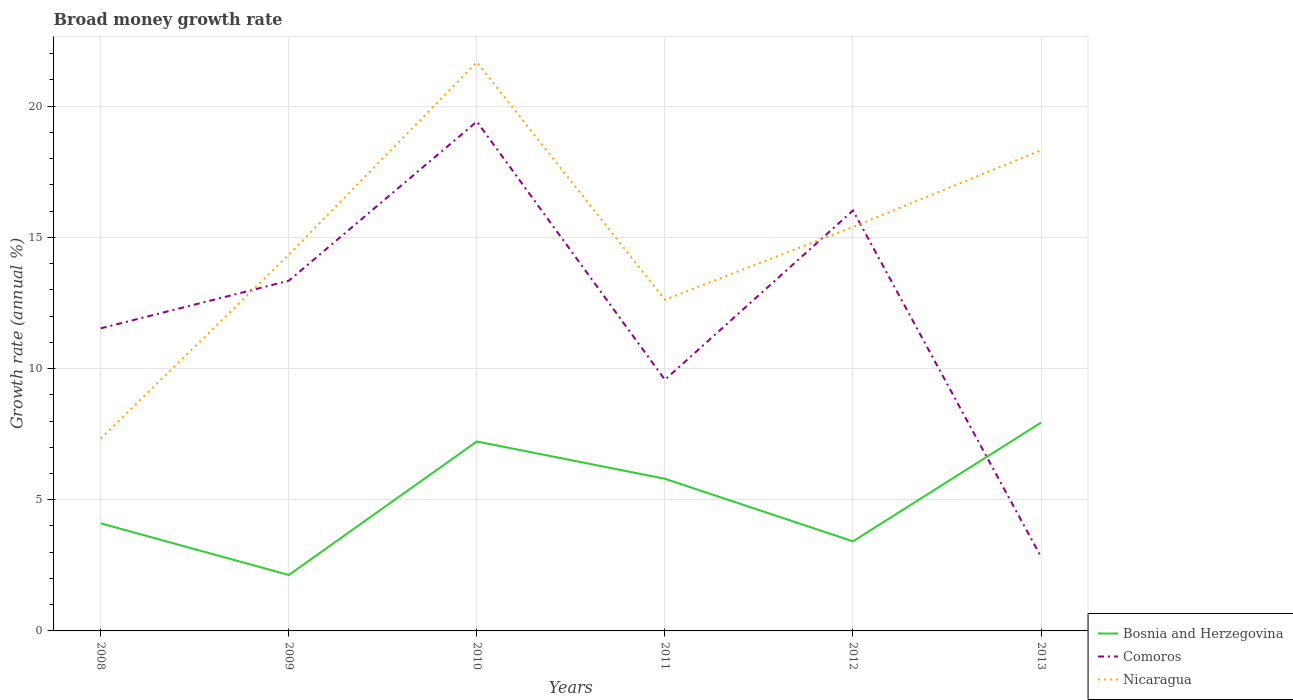Does the line corresponding to Bosnia and Herzegovina intersect with the line corresponding to Nicaragua?
Provide a succinct answer. No. Is the number of lines equal to the number of legend labels?
Ensure brevity in your answer.  Yes. Across all years, what is the maximum growth rate in Comoros?
Offer a very short reply. 2.82. What is the total growth rate in Comoros in the graph?
Your answer should be very brief. -6.45. What is the difference between the highest and the second highest growth rate in Bosnia and Herzegovina?
Give a very brief answer. 5.81. How many lines are there?
Offer a very short reply. 3. How many years are there in the graph?
Provide a succinct answer. 6. Are the values on the major ticks of Y-axis written in scientific E-notation?
Keep it short and to the point. No. Does the graph contain any zero values?
Provide a succinct answer. No. Does the graph contain grids?
Make the answer very short. Yes. Where does the legend appear in the graph?
Provide a short and direct response. Bottom right. How are the legend labels stacked?
Offer a very short reply. Vertical. What is the title of the graph?
Make the answer very short. Broad money growth rate. Does "Lao PDR" appear as one of the legend labels in the graph?
Your response must be concise. No. What is the label or title of the Y-axis?
Your answer should be compact. Growth rate (annual %). What is the Growth rate (annual %) of Bosnia and Herzegovina in 2008?
Make the answer very short. 4.1. What is the Growth rate (annual %) in Comoros in 2008?
Ensure brevity in your answer.  11.53. What is the Growth rate (annual %) in Nicaragua in 2008?
Keep it short and to the point. 7.33. What is the Growth rate (annual %) in Bosnia and Herzegovina in 2009?
Your answer should be compact. 2.13. What is the Growth rate (annual %) in Comoros in 2009?
Your response must be concise. 13.34. What is the Growth rate (annual %) of Nicaragua in 2009?
Your response must be concise. 14.34. What is the Growth rate (annual %) of Bosnia and Herzegovina in 2010?
Your answer should be very brief. 7.22. What is the Growth rate (annual %) in Comoros in 2010?
Offer a terse response. 19.41. What is the Growth rate (annual %) in Nicaragua in 2010?
Provide a short and direct response. 21.67. What is the Growth rate (annual %) of Bosnia and Herzegovina in 2011?
Provide a short and direct response. 5.8. What is the Growth rate (annual %) in Comoros in 2011?
Your response must be concise. 9.57. What is the Growth rate (annual %) in Nicaragua in 2011?
Give a very brief answer. 12.62. What is the Growth rate (annual %) of Bosnia and Herzegovina in 2012?
Ensure brevity in your answer.  3.41. What is the Growth rate (annual %) in Comoros in 2012?
Give a very brief answer. 16.02. What is the Growth rate (annual %) in Nicaragua in 2012?
Your answer should be very brief. 15.39. What is the Growth rate (annual %) in Bosnia and Herzegovina in 2013?
Provide a short and direct response. 7.94. What is the Growth rate (annual %) of Comoros in 2013?
Your answer should be very brief. 2.82. What is the Growth rate (annual %) in Nicaragua in 2013?
Your response must be concise. 18.32. Across all years, what is the maximum Growth rate (annual %) in Bosnia and Herzegovina?
Ensure brevity in your answer.  7.94. Across all years, what is the maximum Growth rate (annual %) in Comoros?
Keep it short and to the point. 19.41. Across all years, what is the maximum Growth rate (annual %) in Nicaragua?
Your answer should be very brief. 21.67. Across all years, what is the minimum Growth rate (annual %) in Bosnia and Herzegovina?
Offer a very short reply. 2.13. Across all years, what is the minimum Growth rate (annual %) of Comoros?
Ensure brevity in your answer.  2.82. Across all years, what is the minimum Growth rate (annual %) of Nicaragua?
Make the answer very short. 7.33. What is the total Growth rate (annual %) of Bosnia and Herzegovina in the graph?
Your response must be concise. 30.6. What is the total Growth rate (annual %) in Comoros in the graph?
Your answer should be compact. 72.7. What is the total Growth rate (annual %) in Nicaragua in the graph?
Give a very brief answer. 89.68. What is the difference between the Growth rate (annual %) in Bosnia and Herzegovina in 2008 and that in 2009?
Your response must be concise. 1.97. What is the difference between the Growth rate (annual %) in Comoros in 2008 and that in 2009?
Your answer should be very brief. -1.81. What is the difference between the Growth rate (annual %) in Nicaragua in 2008 and that in 2009?
Offer a very short reply. -7.01. What is the difference between the Growth rate (annual %) in Bosnia and Herzegovina in 2008 and that in 2010?
Offer a terse response. -3.12. What is the difference between the Growth rate (annual %) of Comoros in 2008 and that in 2010?
Provide a short and direct response. -7.88. What is the difference between the Growth rate (annual %) in Nicaragua in 2008 and that in 2010?
Provide a succinct answer. -14.34. What is the difference between the Growth rate (annual %) in Bosnia and Herzegovina in 2008 and that in 2011?
Give a very brief answer. -1.7. What is the difference between the Growth rate (annual %) of Comoros in 2008 and that in 2011?
Offer a very short reply. 1.96. What is the difference between the Growth rate (annual %) in Nicaragua in 2008 and that in 2011?
Your answer should be very brief. -5.29. What is the difference between the Growth rate (annual %) in Bosnia and Herzegovina in 2008 and that in 2012?
Your answer should be compact. 0.69. What is the difference between the Growth rate (annual %) of Comoros in 2008 and that in 2012?
Ensure brevity in your answer.  -4.49. What is the difference between the Growth rate (annual %) of Nicaragua in 2008 and that in 2012?
Make the answer very short. -8.06. What is the difference between the Growth rate (annual %) of Bosnia and Herzegovina in 2008 and that in 2013?
Your answer should be compact. -3.84. What is the difference between the Growth rate (annual %) of Comoros in 2008 and that in 2013?
Ensure brevity in your answer.  8.71. What is the difference between the Growth rate (annual %) of Nicaragua in 2008 and that in 2013?
Your answer should be compact. -10.99. What is the difference between the Growth rate (annual %) of Bosnia and Herzegovina in 2009 and that in 2010?
Make the answer very short. -5.09. What is the difference between the Growth rate (annual %) in Comoros in 2009 and that in 2010?
Your response must be concise. -6.07. What is the difference between the Growth rate (annual %) in Nicaragua in 2009 and that in 2010?
Your response must be concise. -7.33. What is the difference between the Growth rate (annual %) of Bosnia and Herzegovina in 2009 and that in 2011?
Your response must be concise. -3.67. What is the difference between the Growth rate (annual %) of Comoros in 2009 and that in 2011?
Offer a very short reply. 3.77. What is the difference between the Growth rate (annual %) of Nicaragua in 2009 and that in 2011?
Your answer should be compact. 1.72. What is the difference between the Growth rate (annual %) of Bosnia and Herzegovina in 2009 and that in 2012?
Your response must be concise. -1.28. What is the difference between the Growth rate (annual %) in Comoros in 2009 and that in 2012?
Give a very brief answer. -2.68. What is the difference between the Growth rate (annual %) of Nicaragua in 2009 and that in 2012?
Offer a terse response. -1.05. What is the difference between the Growth rate (annual %) in Bosnia and Herzegovina in 2009 and that in 2013?
Give a very brief answer. -5.81. What is the difference between the Growth rate (annual %) in Comoros in 2009 and that in 2013?
Offer a very short reply. 10.52. What is the difference between the Growth rate (annual %) in Nicaragua in 2009 and that in 2013?
Provide a succinct answer. -3.98. What is the difference between the Growth rate (annual %) of Bosnia and Herzegovina in 2010 and that in 2011?
Ensure brevity in your answer.  1.42. What is the difference between the Growth rate (annual %) in Comoros in 2010 and that in 2011?
Your response must be concise. 9.84. What is the difference between the Growth rate (annual %) in Nicaragua in 2010 and that in 2011?
Your answer should be very brief. 9.05. What is the difference between the Growth rate (annual %) of Bosnia and Herzegovina in 2010 and that in 2012?
Ensure brevity in your answer.  3.8. What is the difference between the Growth rate (annual %) in Comoros in 2010 and that in 2012?
Offer a very short reply. 3.39. What is the difference between the Growth rate (annual %) in Nicaragua in 2010 and that in 2012?
Offer a terse response. 6.28. What is the difference between the Growth rate (annual %) of Bosnia and Herzegovina in 2010 and that in 2013?
Ensure brevity in your answer.  -0.72. What is the difference between the Growth rate (annual %) in Comoros in 2010 and that in 2013?
Your answer should be compact. 16.59. What is the difference between the Growth rate (annual %) of Nicaragua in 2010 and that in 2013?
Your answer should be compact. 3.35. What is the difference between the Growth rate (annual %) in Bosnia and Herzegovina in 2011 and that in 2012?
Your answer should be compact. 2.38. What is the difference between the Growth rate (annual %) of Comoros in 2011 and that in 2012?
Make the answer very short. -6.45. What is the difference between the Growth rate (annual %) in Nicaragua in 2011 and that in 2012?
Offer a terse response. -2.77. What is the difference between the Growth rate (annual %) of Bosnia and Herzegovina in 2011 and that in 2013?
Keep it short and to the point. -2.14. What is the difference between the Growth rate (annual %) of Comoros in 2011 and that in 2013?
Provide a succinct answer. 6.75. What is the difference between the Growth rate (annual %) in Nicaragua in 2011 and that in 2013?
Your answer should be very brief. -5.7. What is the difference between the Growth rate (annual %) of Bosnia and Herzegovina in 2012 and that in 2013?
Provide a succinct answer. -4.53. What is the difference between the Growth rate (annual %) in Comoros in 2012 and that in 2013?
Provide a short and direct response. 13.2. What is the difference between the Growth rate (annual %) of Nicaragua in 2012 and that in 2013?
Make the answer very short. -2.93. What is the difference between the Growth rate (annual %) in Bosnia and Herzegovina in 2008 and the Growth rate (annual %) in Comoros in 2009?
Make the answer very short. -9.24. What is the difference between the Growth rate (annual %) in Bosnia and Herzegovina in 2008 and the Growth rate (annual %) in Nicaragua in 2009?
Offer a very short reply. -10.24. What is the difference between the Growth rate (annual %) of Comoros in 2008 and the Growth rate (annual %) of Nicaragua in 2009?
Offer a very short reply. -2.81. What is the difference between the Growth rate (annual %) in Bosnia and Herzegovina in 2008 and the Growth rate (annual %) in Comoros in 2010?
Your answer should be compact. -15.31. What is the difference between the Growth rate (annual %) in Bosnia and Herzegovina in 2008 and the Growth rate (annual %) in Nicaragua in 2010?
Your answer should be very brief. -17.57. What is the difference between the Growth rate (annual %) in Comoros in 2008 and the Growth rate (annual %) in Nicaragua in 2010?
Give a very brief answer. -10.14. What is the difference between the Growth rate (annual %) in Bosnia and Herzegovina in 2008 and the Growth rate (annual %) in Comoros in 2011?
Provide a succinct answer. -5.47. What is the difference between the Growth rate (annual %) of Bosnia and Herzegovina in 2008 and the Growth rate (annual %) of Nicaragua in 2011?
Keep it short and to the point. -8.52. What is the difference between the Growth rate (annual %) of Comoros in 2008 and the Growth rate (annual %) of Nicaragua in 2011?
Give a very brief answer. -1.09. What is the difference between the Growth rate (annual %) in Bosnia and Herzegovina in 2008 and the Growth rate (annual %) in Comoros in 2012?
Ensure brevity in your answer.  -11.92. What is the difference between the Growth rate (annual %) in Bosnia and Herzegovina in 2008 and the Growth rate (annual %) in Nicaragua in 2012?
Keep it short and to the point. -11.29. What is the difference between the Growth rate (annual %) in Comoros in 2008 and the Growth rate (annual %) in Nicaragua in 2012?
Make the answer very short. -3.86. What is the difference between the Growth rate (annual %) of Bosnia and Herzegovina in 2008 and the Growth rate (annual %) of Comoros in 2013?
Ensure brevity in your answer.  1.28. What is the difference between the Growth rate (annual %) of Bosnia and Herzegovina in 2008 and the Growth rate (annual %) of Nicaragua in 2013?
Offer a terse response. -14.22. What is the difference between the Growth rate (annual %) of Comoros in 2008 and the Growth rate (annual %) of Nicaragua in 2013?
Provide a short and direct response. -6.79. What is the difference between the Growth rate (annual %) in Bosnia and Herzegovina in 2009 and the Growth rate (annual %) in Comoros in 2010?
Offer a terse response. -17.28. What is the difference between the Growth rate (annual %) of Bosnia and Herzegovina in 2009 and the Growth rate (annual %) of Nicaragua in 2010?
Offer a very short reply. -19.54. What is the difference between the Growth rate (annual %) in Comoros in 2009 and the Growth rate (annual %) in Nicaragua in 2010?
Keep it short and to the point. -8.33. What is the difference between the Growth rate (annual %) in Bosnia and Herzegovina in 2009 and the Growth rate (annual %) in Comoros in 2011?
Keep it short and to the point. -7.44. What is the difference between the Growth rate (annual %) in Bosnia and Herzegovina in 2009 and the Growth rate (annual %) in Nicaragua in 2011?
Your answer should be compact. -10.49. What is the difference between the Growth rate (annual %) of Comoros in 2009 and the Growth rate (annual %) of Nicaragua in 2011?
Ensure brevity in your answer.  0.72. What is the difference between the Growth rate (annual %) of Bosnia and Herzegovina in 2009 and the Growth rate (annual %) of Comoros in 2012?
Provide a short and direct response. -13.89. What is the difference between the Growth rate (annual %) in Bosnia and Herzegovina in 2009 and the Growth rate (annual %) in Nicaragua in 2012?
Ensure brevity in your answer.  -13.26. What is the difference between the Growth rate (annual %) of Comoros in 2009 and the Growth rate (annual %) of Nicaragua in 2012?
Provide a short and direct response. -2.05. What is the difference between the Growth rate (annual %) of Bosnia and Herzegovina in 2009 and the Growth rate (annual %) of Comoros in 2013?
Offer a very short reply. -0.69. What is the difference between the Growth rate (annual %) in Bosnia and Herzegovina in 2009 and the Growth rate (annual %) in Nicaragua in 2013?
Your answer should be compact. -16.19. What is the difference between the Growth rate (annual %) of Comoros in 2009 and the Growth rate (annual %) of Nicaragua in 2013?
Your answer should be very brief. -4.97. What is the difference between the Growth rate (annual %) of Bosnia and Herzegovina in 2010 and the Growth rate (annual %) of Comoros in 2011?
Your answer should be very brief. -2.35. What is the difference between the Growth rate (annual %) of Bosnia and Herzegovina in 2010 and the Growth rate (annual %) of Nicaragua in 2011?
Offer a very short reply. -5.4. What is the difference between the Growth rate (annual %) of Comoros in 2010 and the Growth rate (annual %) of Nicaragua in 2011?
Make the answer very short. 6.79. What is the difference between the Growth rate (annual %) in Bosnia and Herzegovina in 2010 and the Growth rate (annual %) in Comoros in 2012?
Provide a short and direct response. -8.8. What is the difference between the Growth rate (annual %) in Bosnia and Herzegovina in 2010 and the Growth rate (annual %) in Nicaragua in 2012?
Keep it short and to the point. -8.17. What is the difference between the Growth rate (annual %) in Comoros in 2010 and the Growth rate (annual %) in Nicaragua in 2012?
Offer a terse response. 4.02. What is the difference between the Growth rate (annual %) in Bosnia and Herzegovina in 2010 and the Growth rate (annual %) in Comoros in 2013?
Your response must be concise. 4.4. What is the difference between the Growth rate (annual %) in Bosnia and Herzegovina in 2010 and the Growth rate (annual %) in Nicaragua in 2013?
Your response must be concise. -11.1. What is the difference between the Growth rate (annual %) of Comoros in 2010 and the Growth rate (annual %) of Nicaragua in 2013?
Provide a succinct answer. 1.09. What is the difference between the Growth rate (annual %) of Bosnia and Herzegovina in 2011 and the Growth rate (annual %) of Comoros in 2012?
Your answer should be very brief. -10.22. What is the difference between the Growth rate (annual %) of Bosnia and Herzegovina in 2011 and the Growth rate (annual %) of Nicaragua in 2012?
Ensure brevity in your answer.  -9.6. What is the difference between the Growth rate (annual %) of Comoros in 2011 and the Growth rate (annual %) of Nicaragua in 2012?
Your answer should be compact. -5.82. What is the difference between the Growth rate (annual %) of Bosnia and Herzegovina in 2011 and the Growth rate (annual %) of Comoros in 2013?
Your answer should be very brief. 2.98. What is the difference between the Growth rate (annual %) of Bosnia and Herzegovina in 2011 and the Growth rate (annual %) of Nicaragua in 2013?
Your response must be concise. -12.52. What is the difference between the Growth rate (annual %) in Comoros in 2011 and the Growth rate (annual %) in Nicaragua in 2013?
Keep it short and to the point. -8.75. What is the difference between the Growth rate (annual %) of Bosnia and Herzegovina in 2012 and the Growth rate (annual %) of Comoros in 2013?
Offer a very short reply. 0.59. What is the difference between the Growth rate (annual %) in Bosnia and Herzegovina in 2012 and the Growth rate (annual %) in Nicaragua in 2013?
Your response must be concise. -14.9. What is the difference between the Growth rate (annual %) in Comoros in 2012 and the Growth rate (annual %) in Nicaragua in 2013?
Make the answer very short. -2.3. What is the average Growth rate (annual %) of Bosnia and Herzegovina per year?
Your answer should be compact. 5.1. What is the average Growth rate (annual %) of Comoros per year?
Your answer should be compact. 12.12. What is the average Growth rate (annual %) in Nicaragua per year?
Your answer should be compact. 14.95. In the year 2008, what is the difference between the Growth rate (annual %) in Bosnia and Herzegovina and Growth rate (annual %) in Comoros?
Provide a succinct answer. -7.43. In the year 2008, what is the difference between the Growth rate (annual %) of Bosnia and Herzegovina and Growth rate (annual %) of Nicaragua?
Provide a short and direct response. -3.23. In the year 2008, what is the difference between the Growth rate (annual %) in Comoros and Growth rate (annual %) in Nicaragua?
Provide a short and direct response. 4.2. In the year 2009, what is the difference between the Growth rate (annual %) of Bosnia and Herzegovina and Growth rate (annual %) of Comoros?
Provide a short and direct response. -11.21. In the year 2009, what is the difference between the Growth rate (annual %) of Bosnia and Herzegovina and Growth rate (annual %) of Nicaragua?
Provide a succinct answer. -12.21. In the year 2009, what is the difference between the Growth rate (annual %) of Comoros and Growth rate (annual %) of Nicaragua?
Ensure brevity in your answer.  -0.99. In the year 2010, what is the difference between the Growth rate (annual %) in Bosnia and Herzegovina and Growth rate (annual %) in Comoros?
Ensure brevity in your answer.  -12.19. In the year 2010, what is the difference between the Growth rate (annual %) in Bosnia and Herzegovina and Growth rate (annual %) in Nicaragua?
Your answer should be very brief. -14.45. In the year 2010, what is the difference between the Growth rate (annual %) of Comoros and Growth rate (annual %) of Nicaragua?
Your response must be concise. -2.26. In the year 2011, what is the difference between the Growth rate (annual %) of Bosnia and Herzegovina and Growth rate (annual %) of Comoros?
Ensure brevity in your answer.  -3.77. In the year 2011, what is the difference between the Growth rate (annual %) in Bosnia and Herzegovina and Growth rate (annual %) in Nicaragua?
Offer a very short reply. -6.82. In the year 2011, what is the difference between the Growth rate (annual %) of Comoros and Growth rate (annual %) of Nicaragua?
Your answer should be very brief. -3.05. In the year 2012, what is the difference between the Growth rate (annual %) of Bosnia and Herzegovina and Growth rate (annual %) of Comoros?
Provide a succinct answer. -12.61. In the year 2012, what is the difference between the Growth rate (annual %) in Bosnia and Herzegovina and Growth rate (annual %) in Nicaragua?
Ensure brevity in your answer.  -11.98. In the year 2012, what is the difference between the Growth rate (annual %) of Comoros and Growth rate (annual %) of Nicaragua?
Provide a short and direct response. 0.63. In the year 2013, what is the difference between the Growth rate (annual %) of Bosnia and Herzegovina and Growth rate (annual %) of Comoros?
Keep it short and to the point. 5.12. In the year 2013, what is the difference between the Growth rate (annual %) of Bosnia and Herzegovina and Growth rate (annual %) of Nicaragua?
Provide a succinct answer. -10.38. In the year 2013, what is the difference between the Growth rate (annual %) of Comoros and Growth rate (annual %) of Nicaragua?
Your answer should be compact. -15.5. What is the ratio of the Growth rate (annual %) in Bosnia and Herzegovina in 2008 to that in 2009?
Ensure brevity in your answer.  1.92. What is the ratio of the Growth rate (annual %) of Comoros in 2008 to that in 2009?
Your answer should be compact. 0.86. What is the ratio of the Growth rate (annual %) of Nicaragua in 2008 to that in 2009?
Give a very brief answer. 0.51. What is the ratio of the Growth rate (annual %) in Bosnia and Herzegovina in 2008 to that in 2010?
Offer a terse response. 0.57. What is the ratio of the Growth rate (annual %) of Comoros in 2008 to that in 2010?
Keep it short and to the point. 0.59. What is the ratio of the Growth rate (annual %) in Nicaragua in 2008 to that in 2010?
Make the answer very short. 0.34. What is the ratio of the Growth rate (annual %) of Bosnia and Herzegovina in 2008 to that in 2011?
Offer a terse response. 0.71. What is the ratio of the Growth rate (annual %) in Comoros in 2008 to that in 2011?
Make the answer very short. 1.2. What is the ratio of the Growth rate (annual %) of Nicaragua in 2008 to that in 2011?
Your answer should be very brief. 0.58. What is the ratio of the Growth rate (annual %) of Bosnia and Herzegovina in 2008 to that in 2012?
Ensure brevity in your answer.  1.2. What is the ratio of the Growth rate (annual %) in Comoros in 2008 to that in 2012?
Provide a short and direct response. 0.72. What is the ratio of the Growth rate (annual %) of Nicaragua in 2008 to that in 2012?
Ensure brevity in your answer.  0.48. What is the ratio of the Growth rate (annual %) of Bosnia and Herzegovina in 2008 to that in 2013?
Make the answer very short. 0.52. What is the ratio of the Growth rate (annual %) of Comoros in 2008 to that in 2013?
Make the answer very short. 4.09. What is the ratio of the Growth rate (annual %) in Nicaragua in 2008 to that in 2013?
Ensure brevity in your answer.  0.4. What is the ratio of the Growth rate (annual %) in Bosnia and Herzegovina in 2009 to that in 2010?
Offer a very short reply. 0.3. What is the ratio of the Growth rate (annual %) in Comoros in 2009 to that in 2010?
Your answer should be compact. 0.69. What is the ratio of the Growth rate (annual %) in Nicaragua in 2009 to that in 2010?
Give a very brief answer. 0.66. What is the ratio of the Growth rate (annual %) of Bosnia and Herzegovina in 2009 to that in 2011?
Give a very brief answer. 0.37. What is the ratio of the Growth rate (annual %) of Comoros in 2009 to that in 2011?
Your answer should be compact. 1.39. What is the ratio of the Growth rate (annual %) in Nicaragua in 2009 to that in 2011?
Your answer should be compact. 1.14. What is the ratio of the Growth rate (annual %) of Bosnia and Herzegovina in 2009 to that in 2012?
Your response must be concise. 0.62. What is the ratio of the Growth rate (annual %) of Comoros in 2009 to that in 2012?
Make the answer very short. 0.83. What is the ratio of the Growth rate (annual %) of Nicaragua in 2009 to that in 2012?
Ensure brevity in your answer.  0.93. What is the ratio of the Growth rate (annual %) in Bosnia and Herzegovina in 2009 to that in 2013?
Ensure brevity in your answer.  0.27. What is the ratio of the Growth rate (annual %) of Comoros in 2009 to that in 2013?
Your answer should be very brief. 4.73. What is the ratio of the Growth rate (annual %) of Nicaragua in 2009 to that in 2013?
Your response must be concise. 0.78. What is the ratio of the Growth rate (annual %) in Bosnia and Herzegovina in 2010 to that in 2011?
Ensure brevity in your answer.  1.25. What is the ratio of the Growth rate (annual %) in Comoros in 2010 to that in 2011?
Keep it short and to the point. 2.03. What is the ratio of the Growth rate (annual %) in Nicaragua in 2010 to that in 2011?
Provide a succinct answer. 1.72. What is the ratio of the Growth rate (annual %) in Bosnia and Herzegovina in 2010 to that in 2012?
Keep it short and to the point. 2.11. What is the ratio of the Growth rate (annual %) in Comoros in 2010 to that in 2012?
Your answer should be very brief. 1.21. What is the ratio of the Growth rate (annual %) of Nicaragua in 2010 to that in 2012?
Your answer should be very brief. 1.41. What is the ratio of the Growth rate (annual %) of Bosnia and Herzegovina in 2010 to that in 2013?
Give a very brief answer. 0.91. What is the ratio of the Growth rate (annual %) of Comoros in 2010 to that in 2013?
Provide a short and direct response. 6.88. What is the ratio of the Growth rate (annual %) in Nicaragua in 2010 to that in 2013?
Offer a terse response. 1.18. What is the ratio of the Growth rate (annual %) in Bosnia and Herzegovina in 2011 to that in 2012?
Keep it short and to the point. 1.7. What is the ratio of the Growth rate (annual %) in Comoros in 2011 to that in 2012?
Offer a very short reply. 0.6. What is the ratio of the Growth rate (annual %) in Nicaragua in 2011 to that in 2012?
Offer a terse response. 0.82. What is the ratio of the Growth rate (annual %) in Bosnia and Herzegovina in 2011 to that in 2013?
Give a very brief answer. 0.73. What is the ratio of the Growth rate (annual %) of Comoros in 2011 to that in 2013?
Your answer should be very brief. 3.39. What is the ratio of the Growth rate (annual %) of Nicaragua in 2011 to that in 2013?
Your answer should be compact. 0.69. What is the ratio of the Growth rate (annual %) of Bosnia and Herzegovina in 2012 to that in 2013?
Your response must be concise. 0.43. What is the ratio of the Growth rate (annual %) of Comoros in 2012 to that in 2013?
Give a very brief answer. 5.68. What is the ratio of the Growth rate (annual %) of Nicaragua in 2012 to that in 2013?
Provide a short and direct response. 0.84. What is the difference between the highest and the second highest Growth rate (annual %) in Bosnia and Herzegovina?
Keep it short and to the point. 0.72. What is the difference between the highest and the second highest Growth rate (annual %) in Comoros?
Your response must be concise. 3.39. What is the difference between the highest and the second highest Growth rate (annual %) in Nicaragua?
Offer a very short reply. 3.35. What is the difference between the highest and the lowest Growth rate (annual %) in Bosnia and Herzegovina?
Offer a terse response. 5.81. What is the difference between the highest and the lowest Growth rate (annual %) in Comoros?
Ensure brevity in your answer.  16.59. What is the difference between the highest and the lowest Growth rate (annual %) of Nicaragua?
Make the answer very short. 14.34. 